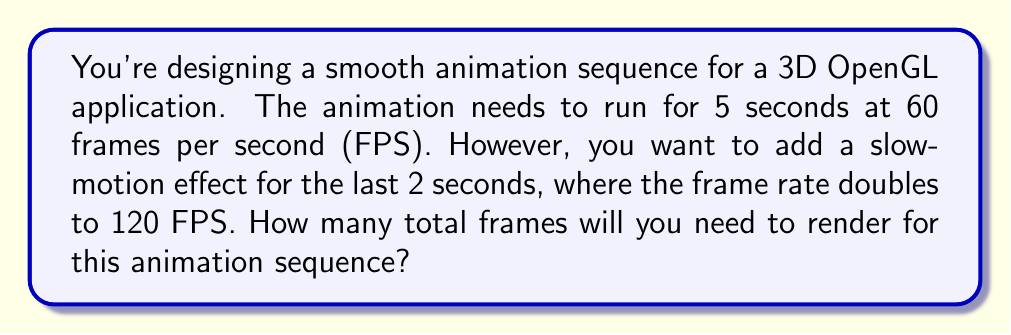Teach me how to tackle this problem. Let's break this down step-by-step:

1. First, let's calculate the number of frames for the regular speed portion:
   - Duration: 3 seconds (5 seconds total - 2 seconds slow-motion)
   - Frame rate: 60 FPS
   - Number of frames: $3 \text{ seconds} \times 60 \text{ FPS} = 180 \text{ frames}$

2. Now, let's calculate the number of frames for the slow-motion portion:
   - Duration: 2 seconds
   - Frame rate: 120 FPS
   - Number of frames: $2 \text{ seconds} \times 120 \text{ FPS} = 240 \text{ frames}$

3. To get the total number of frames, we add the results from steps 1 and 2:
   $$\text{Total frames} = 180 + 240 = 420 \text{ frames}$$

Therefore, you will need to render 420 frames for this animation sequence.
Answer: 420 frames 